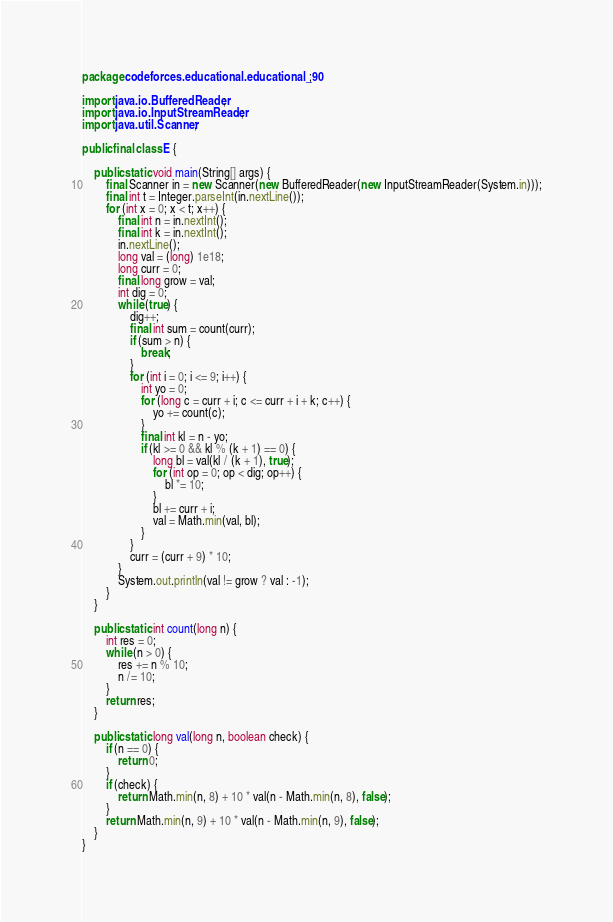Convert code to text. <code><loc_0><loc_0><loc_500><loc_500><_Java_>package codeforces.educational.educational_90;

import java.io.BufferedReader;
import java.io.InputStreamReader;
import java.util.Scanner;

public final class E {

    public static void main(String[] args) {
        final Scanner in = new Scanner(new BufferedReader(new InputStreamReader(System.in)));
        final int t = Integer.parseInt(in.nextLine());
        for (int x = 0; x < t; x++) {
            final int n = in.nextInt();
            final int k = in.nextInt();
            in.nextLine();
            long val = (long) 1e18;
            long curr = 0;
            final long grow = val;
            int dig = 0;
            while (true) {
                dig++;
                final int sum = count(curr);
                if (sum > n) {
                    break;
                }
                for (int i = 0; i <= 9; i++) {
                    int yo = 0;
                    for (long c = curr + i; c <= curr + i + k; c++) {
                        yo += count(c);
                    }
                    final int kl = n - yo;
                    if (kl >= 0 && kl % (k + 1) == 0) {
                        long bl = val(kl / (k + 1), true);
                        for (int op = 0; op < dig; op++) {
                            bl *= 10;
                        }
                        bl += curr + i;
                        val = Math.min(val, bl);
                    }
                }
                curr = (curr + 9) * 10;
            }
            System.out.println(val != grow ? val : -1);
        }
    }

    public static int count(long n) {
        int res = 0;
        while (n > 0) {
            res += n % 10;
            n /= 10;
        }
        return res;
    }

    public static long val(long n, boolean check) {
        if (n == 0) {
            return 0;
        }
        if (check) {
            return Math.min(n, 8) + 10 * val(n - Math.min(n, 8), false);
        }
        return Math.min(n, 9) + 10 * val(n - Math.min(n, 9), false);
    }
}
</code> 